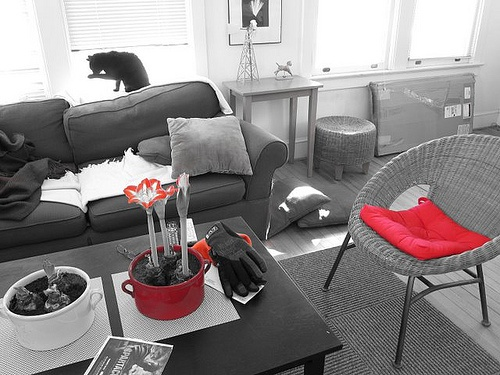Describe the objects in this image and their specific colors. I can see couch in white, black, gray, and darkgray tones, chair in white, gray, brown, and black tones, potted plant in white, black, maroon, gray, and darkgray tones, potted plant in white, darkgray, black, gray, and lightgray tones, and baseball glove in white, black, gray, darkgray, and maroon tones in this image. 